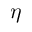<formula> <loc_0><loc_0><loc_500><loc_500>\eta</formula> 